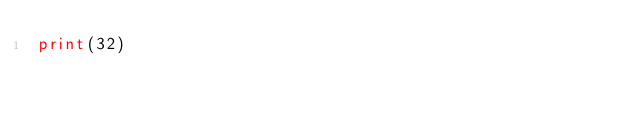<code> <loc_0><loc_0><loc_500><loc_500><_Python_>print(32)</code> 